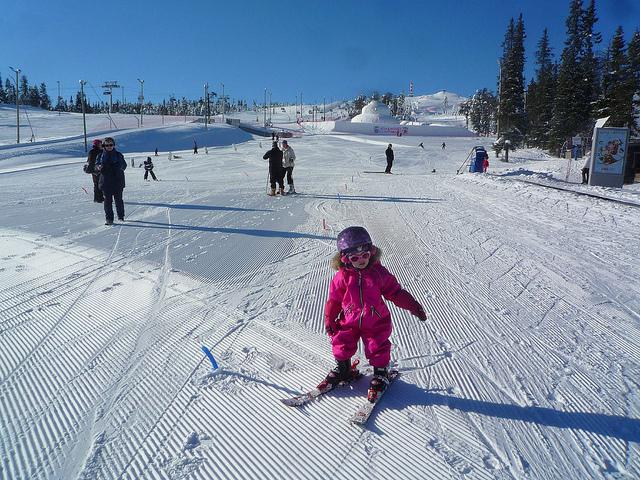Is the person in pink an adult?
Quick response, please. No. What color is her snowsuit?
Concise answer only. Pink. Is the ski trail well used?
Quick response, please. Yes. What color are the skier's pants?
Keep it brief. Pink. Is there any clouds in the sky?
Keep it brief. No. How many tracks are imprinted on the snow?
Quick response, please. Many. 